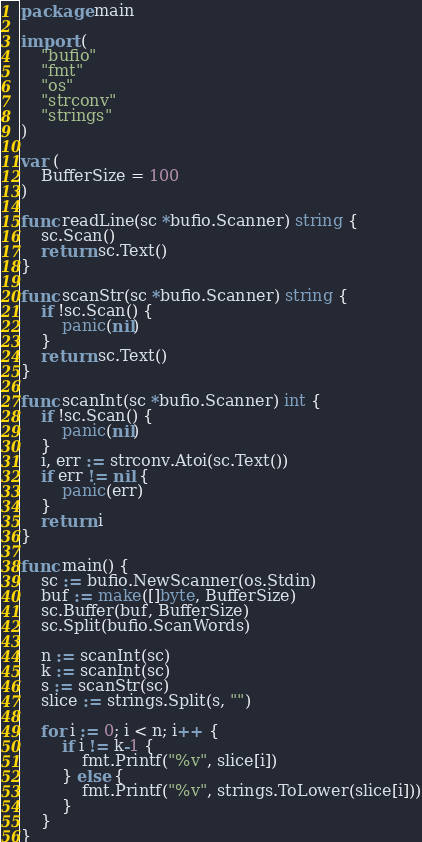Convert code to text. <code><loc_0><loc_0><loc_500><loc_500><_Go_>package main

import (
	"bufio"
	"fmt"
	"os"
	"strconv"
	"strings"
)

var (
	BufferSize = 100
)

func readLine(sc *bufio.Scanner) string {
	sc.Scan()
	return sc.Text()
}

func scanStr(sc *bufio.Scanner) string {
	if !sc.Scan() {
		panic(nil)
	}
	return sc.Text()
}

func scanInt(sc *bufio.Scanner) int {
	if !sc.Scan() {
		panic(nil)
	}
	i, err := strconv.Atoi(sc.Text())
	if err != nil {
		panic(err)
	}
	return i
}

func main() {
	sc := bufio.NewScanner(os.Stdin)
	buf := make([]byte, BufferSize)
	sc.Buffer(buf, BufferSize)
	sc.Split(bufio.ScanWords)

	n := scanInt(sc)
	k := scanInt(sc)
	s := scanStr(sc)
	slice := strings.Split(s, "")

	for i := 0; i < n; i++ {
		if i != k-1 {
			fmt.Printf("%v", slice[i])
		} else {
			fmt.Printf("%v", strings.ToLower(slice[i]))
		}
	}
}
</code> 